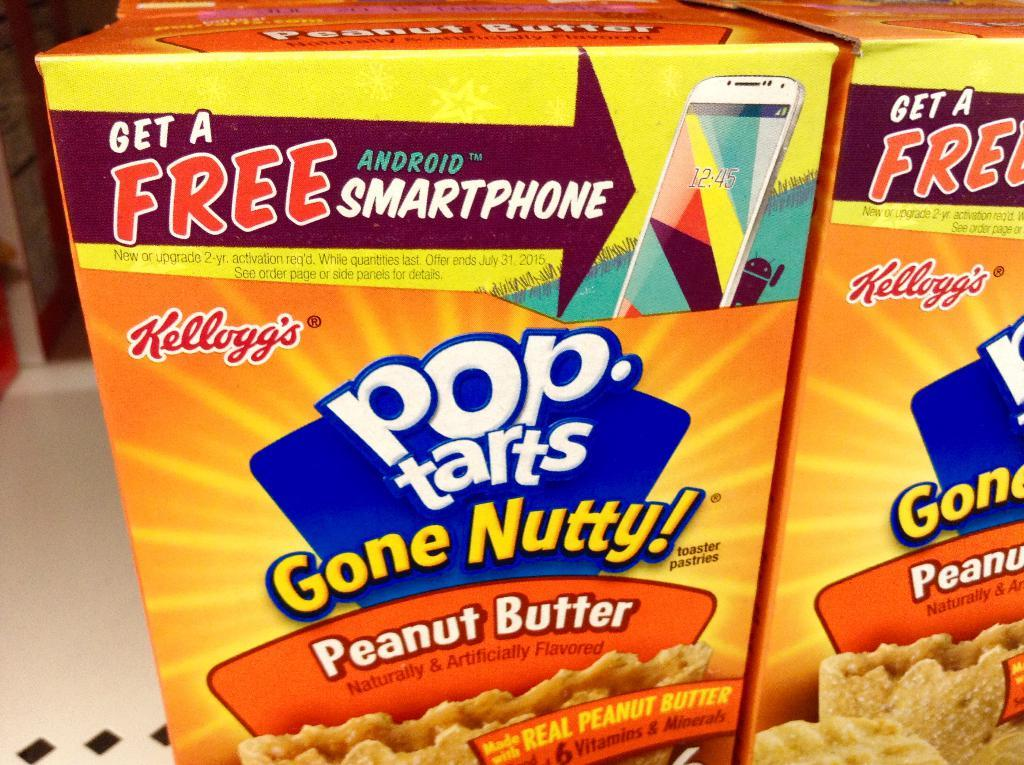<image>
Render a clear and concise summary of the photo. Boxes of Pop Tarts that advertise a free Android smartphone. 